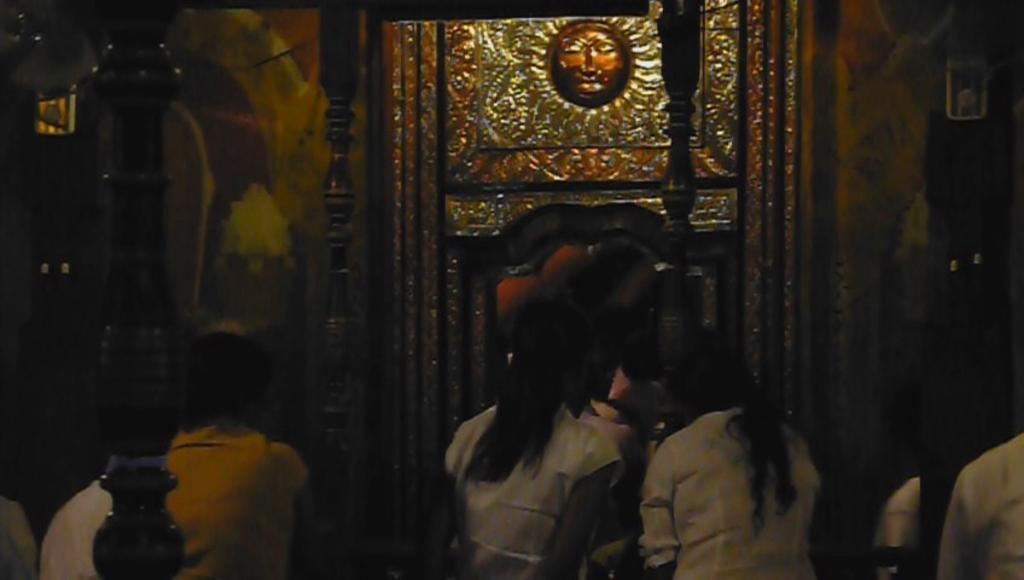What type of objects can be seen in the image? There are wooden poles in the image. Are there any people present in the image? Yes, there are people in the image. What can be seen in the background of the image? There is a wall visible in the background of the image. What is the appearance of the wall? The wall has a silver coating. How can someone enter or exit the area in the image? There is an entrance in the image. Can you tell me how many crooks are present near the seashore in the image? There is no seashore or crooks present in the image; it features wooden poles, people, a wall, and an entrance. How are the wooden poles being sorted in the image? The wooden poles are not being sorted in the image; they are simply standing upright. 